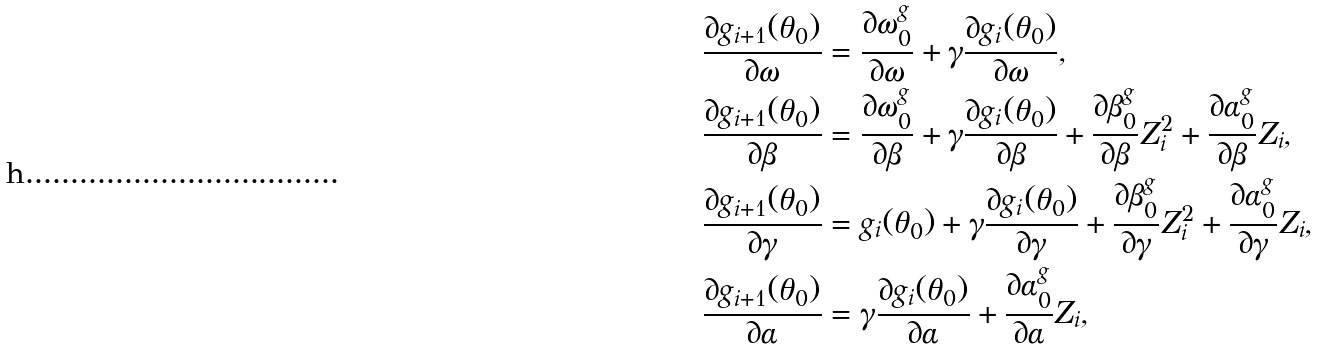<formula> <loc_0><loc_0><loc_500><loc_500>& \frac { \partial g _ { i + 1 } ( \theta _ { 0 } ) } { \partial \omega } = \frac { \partial \omega _ { 0 } ^ { g } } { \partial \omega } + \gamma \frac { \partial g _ { i } ( \theta _ { 0 } ) } { \partial \omega } , \\ & \frac { \partial g _ { i + 1 } ( \theta _ { 0 } ) } { \partial \beta } = \frac { \partial \omega _ { 0 } ^ { g } } { \partial \beta } + \gamma \frac { \partial g _ { i } ( \theta _ { 0 } ) } { \partial \beta } + \frac { \partial \beta _ { 0 } ^ { g } } { \partial \beta } Z _ { i } ^ { 2 } + \frac { \partial \alpha _ { 0 } ^ { g } } { \partial \beta } Z _ { i } , \\ & \frac { \partial g _ { i + 1 } ( \theta _ { 0 } ) } { \partial \gamma } = g _ { i } ( \theta _ { 0 } ) + \gamma \frac { \partial g _ { i } ( \theta _ { 0 } ) } { \partial \gamma } + \frac { \partial \beta _ { 0 } ^ { g } } { \partial \gamma } Z _ { i } ^ { 2 } + \frac { \partial \alpha _ { 0 } ^ { g } } { \partial \gamma } Z _ { i } , \\ & \frac { \partial g _ { i + 1 } ( \theta _ { 0 } ) } { \partial \alpha } = \gamma \frac { \partial g _ { i } ( \theta _ { 0 } ) } { \partial \alpha } + \frac { \partial \alpha _ { 0 } ^ { g } } { \partial \alpha } Z _ { i } ,</formula> 